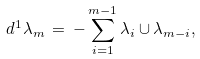Convert formula to latex. <formula><loc_0><loc_0><loc_500><loc_500>d ^ { 1 } \lambda _ { m } \, = \, - \sum _ { i = 1 } ^ { m - 1 } \lambda _ { i } \cup \lambda _ { m - i } ,</formula> 